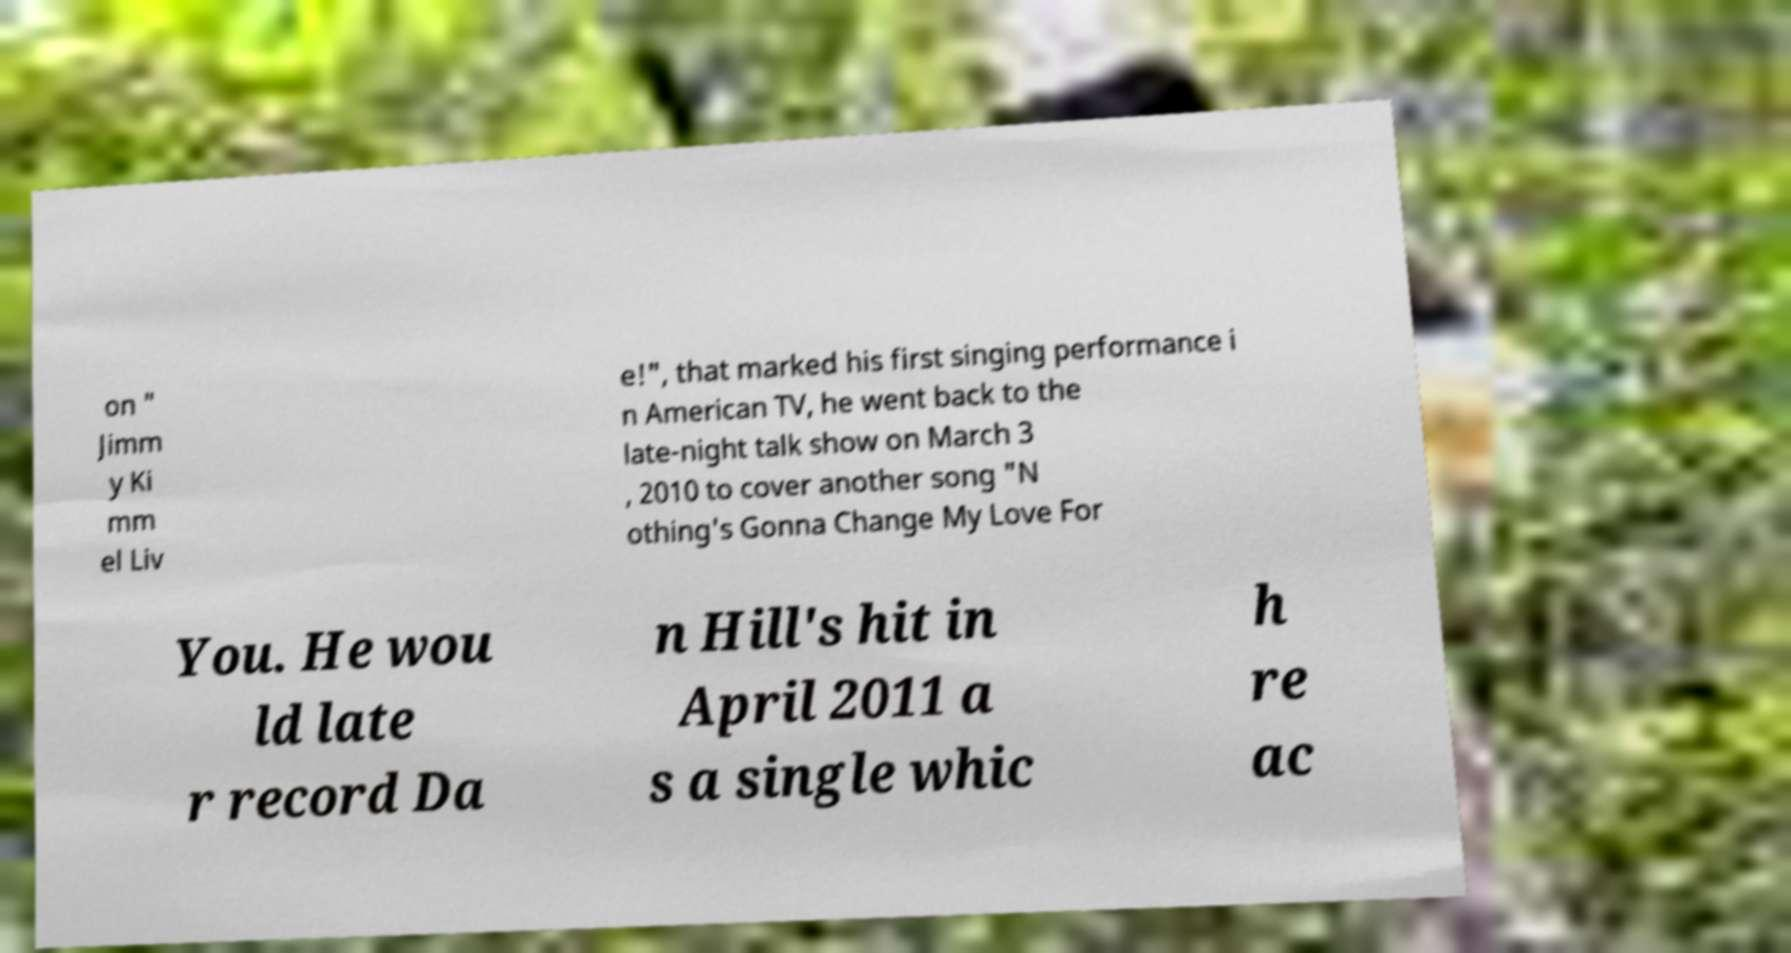There's text embedded in this image that I need extracted. Can you transcribe it verbatim? on " Jimm y Ki mm el Liv e!", that marked his first singing performance i n American TV, he went back to the late-night talk show on March 3 , 2010 to cover another song "N othing's Gonna Change My Love For You. He wou ld late r record Da n Hill's hit in April 2011 a s a single whic h re ac 